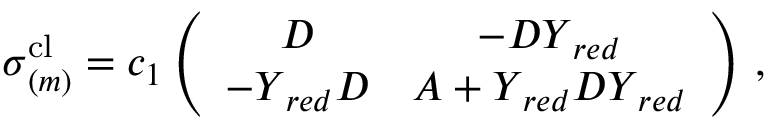Convert formula to latex. <formula><loc_0><loc_0><loc_500><loc_500>\begin{array} { r } { \sigma _ { ( m ) } ^ { c l } = c _ { 1 } \left ( \begin{array} { c c } { D } & { - D Y _ { r e d } } \\ { - Y _ { r e d } D } & { A + Y _ { r e d } D Y _ { r e d } } \end{array} \right ) \, , } \end{array}</formula> 